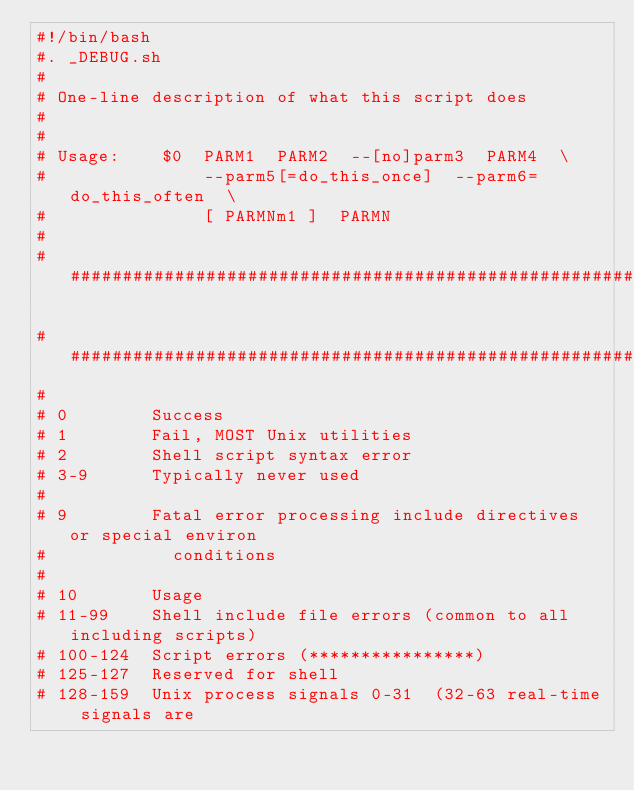Convert code to text. <code><loc_0><loc_0><loc_500><loc_500><_Bash_>#!/bin/bash
#. _DEBUG.sh
#
# One-line description of what this script does
#
#
# Usage:    $0  PARM1  PARM2  --[no]parm3  PARM4  \
#               --parm5[=do_this_once]  --parm6=do_this_often  \
#               [ PARMNm1 ]  PARMN
#
########################################################################

########################################################################
#
# 0        Success
# 1        Fail, MOST Unix utilities
# 2        Shell script syntax error
# 3-9      Typically never used
#
# 9        Fatal error processing include directives or special environ
#            conditions
#
# 10       Usage
# 11-99    Shell include file errors (common to all including scripts)
# 100-124  Script errors (****************)
# 125-127  Reserved for shell
# 128-159  Unix process signals 0-31  (32-63 real-time signals are</code> 